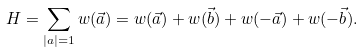<formula> <loc_0><loc_0><loc_500><loc_500>H = \sum _ { | a | = 1 } w ( \vec { a } ) = w ( \vec { a } ) + w ( \vec { b } ) + w ( - \vec { a } ) + w ( - \vec { b } ) .</formula> 